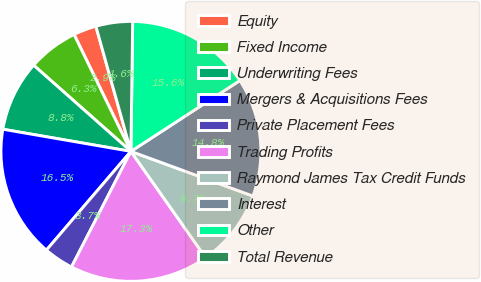<chart> <loc_0><loc_0><loc_500><loc_500><pie_chart><fcel>Equity<fcel>Fixed Income<fcel>Underwriting Fees<fcel>Mergers & Acquisitions Fees<fcel>Private Placement Fees<fcel>Trading Profits<fcel>Raymond James Tax Credit Funds<fcel>Interest<fcel>Other<fcel>Total Revenue<nl><fcel>2.86%<fcel>6.26%<fcel>8.81%<fcel>16.46%<fcel>3.71%<fcel>17.31%<fcel>9.66%<fcel>14.76%<fcel>15.61%<fcel>4.56%<nl></chart> 